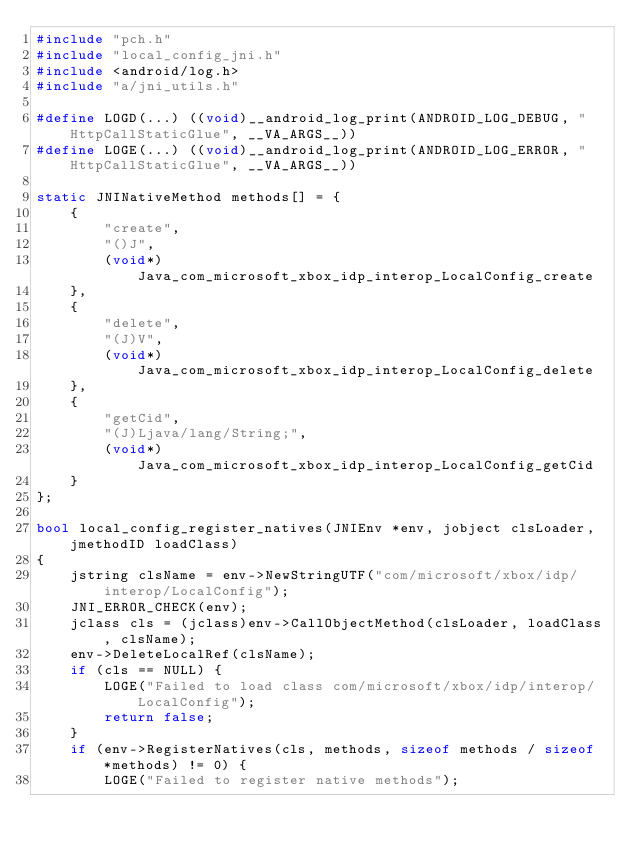Convert code to text. <code><loc_0><loc_0><loc_500><loc_500><_C++_>#include "pch.h"
#include "local_config_jni.h"
#include <android/log.h>
#include "a/jni_utils.h"

#define LOGD(...) ((void)__android_log_print(ANDROID_LOG_DEBUG, "HttpCallStaticGlue", __VA_ARGS__))
#define LOGE(...) ((void)__android_log_print(ANDROID_LOG_ERROR, "HttpCallStaticGlue", __VA_ARGS__))

static JNINativeMethod methods[] = {
    {
        "create",
        "()J",
        (void*)Java_com_microsoft_xbox_idp_interop_LocalConfig_create
    },
    {
        "delete",
        "(J)V",
        (void*)Java_com_microsoft_xbox_idp_interop_LocalConfig_delete
    },
    {
        "getCid",
        "(J)Ljava/lang/String;",
        (void*)Java_com_microsoft_xbox_idp_interop_LocalConfig_getCid
    }
};

bool local_config_register_natives(JNIEnv *env, jobject clsLoader, jmethodID loadClass)
{
    jstring clsName = env->NewStringUTF("com/microsoft/xbox/idp/interop/LocalConfig");
    JNI_ERROR_CHECK(env);
    jclass cls = (jclass)env->CallObjectMethod(clsLoader, loadClass, clsName);
    env->DeleteLocalRef(clsName);
    if (cls == NULL) {
        LOGE("Failed to load class com/microsoft/xbox/idp/interop/LocalConfig");
        return false;
    }
    if (env->RegisterNatives(cls, methods, sizeof methods / sizeof *methods) != 0) {
        LOGE("Failed to register native methods");</code> 